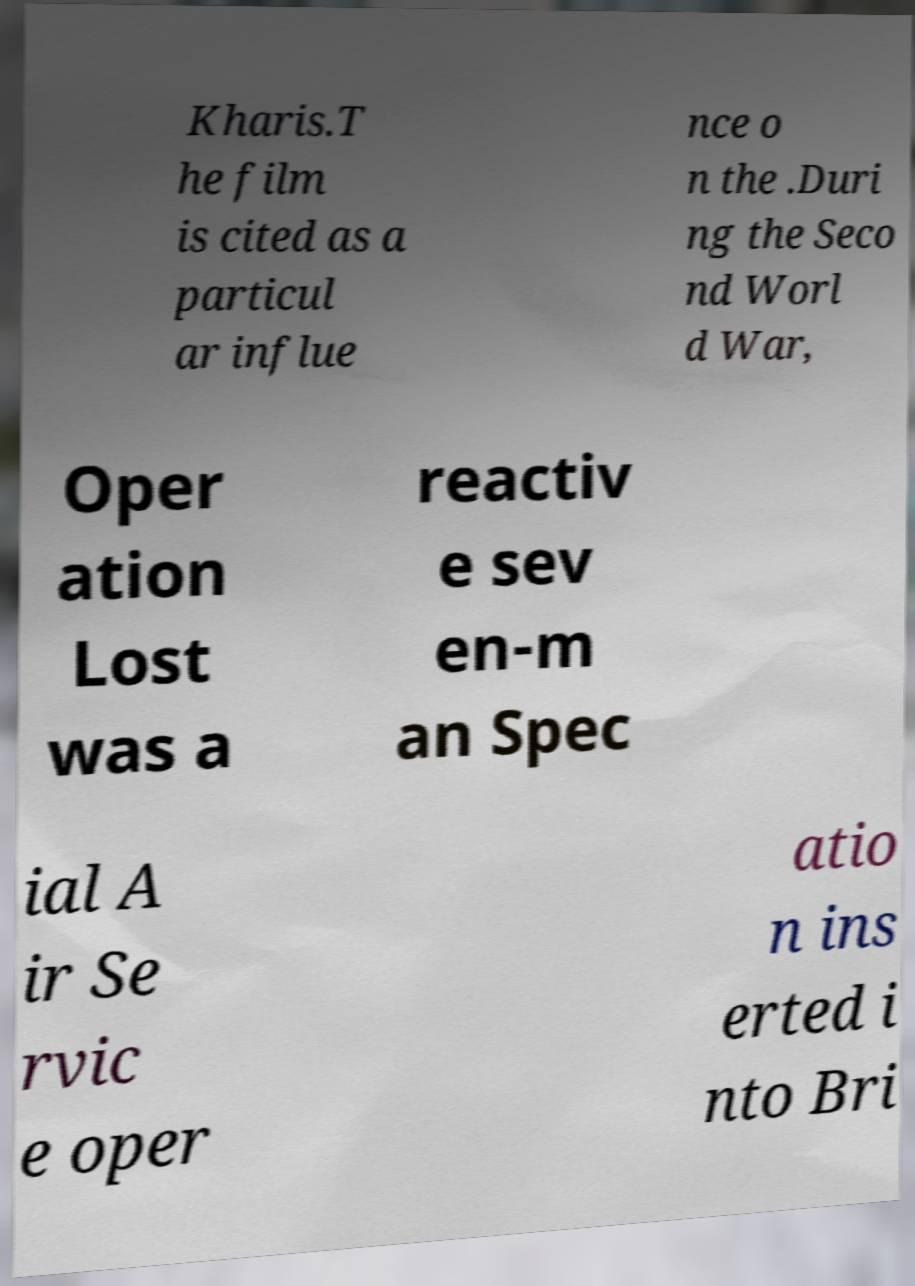Can you accurately transcribe the text from the provided image for me? Kharis.T he film is cited as a particul ar influe nce o n the .Duri ng the Seco nd Worl d War, Oper ation Lost was a reactiv e sev en-m an Spec ial A ir Se rvic e oper atio n ins erted i nto Bri 